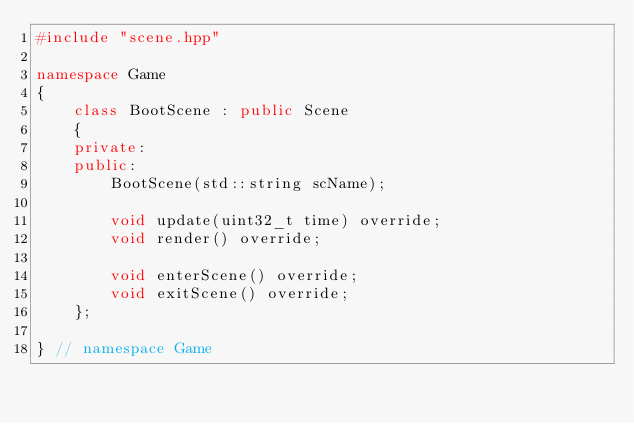<code> <loc_0><loc_0><loc_500><loc_500><_C++_>#include "scene.hpp"

namespace Game
{
    class BootScene : public Scene
    {
    private:
    public:
        BootScene(std::string scName);

        void update(uint32_t time) override;
        void render() override;

        void enterScene() override;
        void exitScene() override;
    };

} // namespace Game</code> 